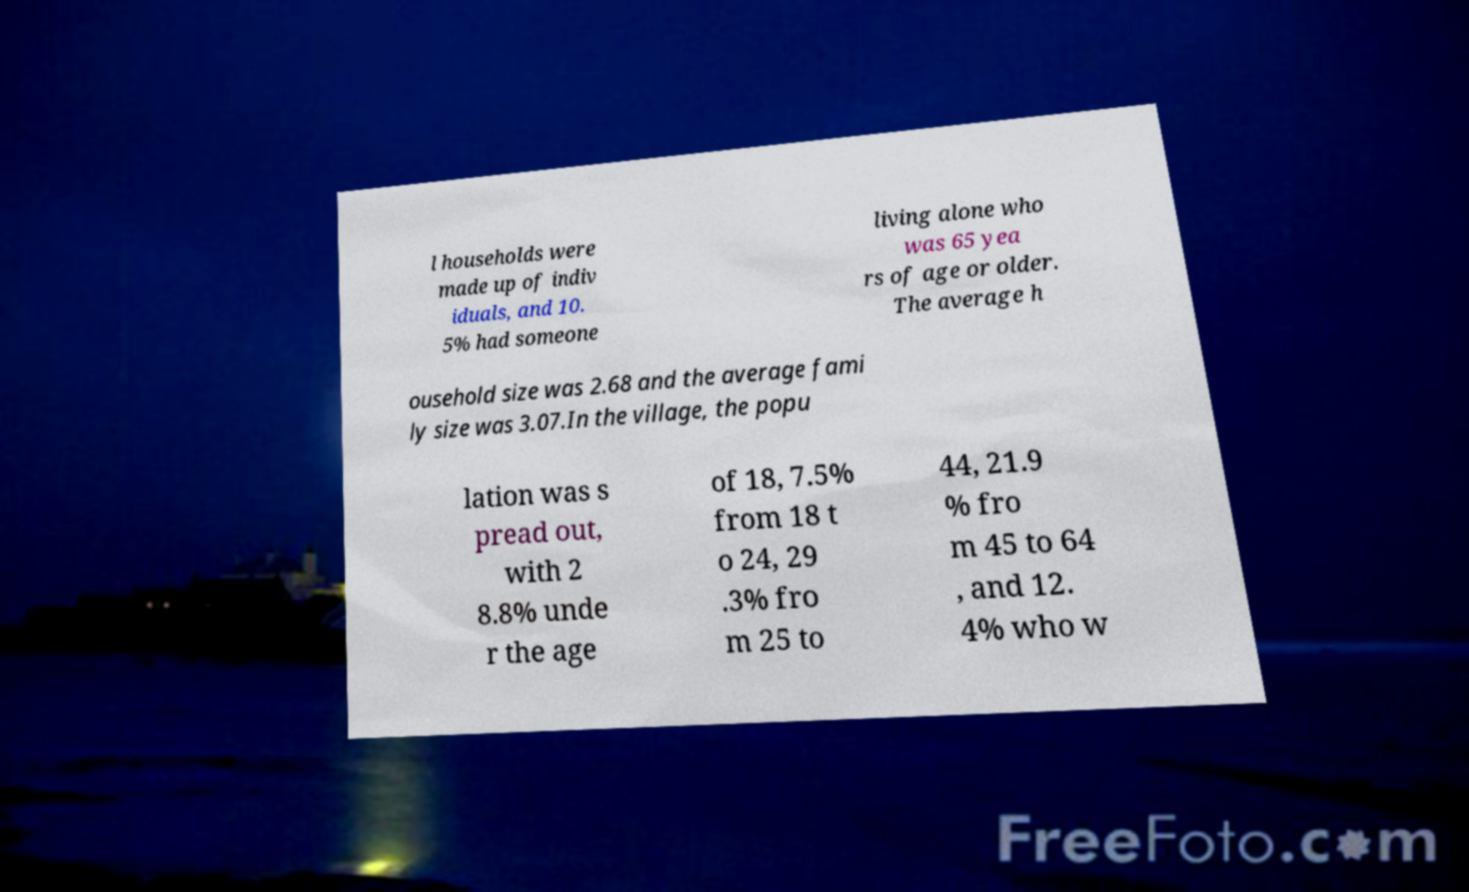For documentation purposes, I need the text within this image transcribed. Could you provide that? l households were made up of indiv iduals, and 10. 5% had someone living alone who was 65 yea rs of age or older. The average h ousehold size was 2.68 and the average fami ly size was 3.07.In the village, the popu lation was s pread out, with 2 8.8% unde r the age of 18, 7.5% from 18 t o 24, 29 .3% fro m 25 to 44, 21.9 % fro m 45 to 64 , and 12. 4% who w 